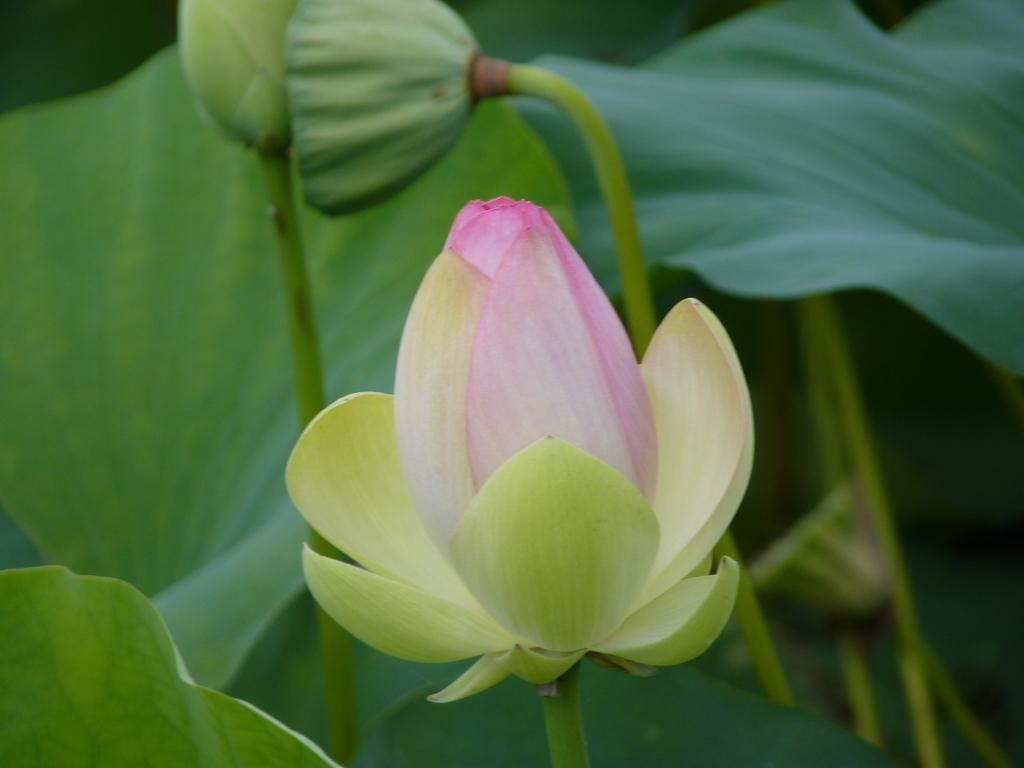What is present in the image? There is a plant in the image. What specific part of the plant is visible? The plant has a flower. What else can be seen in the background of the image? There are green leaves in the background of the image. What type of crime is being committed in the image? There is no crime present in the image; it features a plant with a flower and green leaves in the background. How many cherries are on the plant in the image? There are no cherries present in the image; it features a plant with a flower and green leaves in the background. 